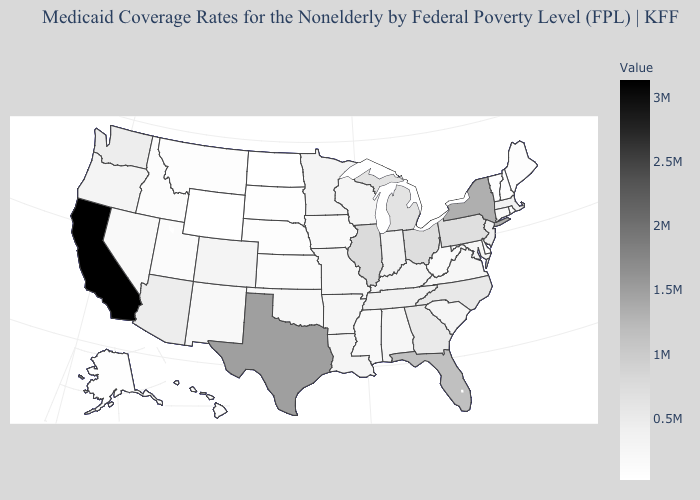Is the legend a continuous bar?
Short answer required. Yes. Which states have the lowest value in the Northeast?
Keep it brief. Vermont. Is the legend a continuous bar?
Be succinct. Yes. Among the states that border Rhode Island , which have the highest value?
Give a very brief answer. Massachusetts. Among the states that border Louisiana , which have the lowest value?
Concise answer only. Mississippi. Does California have the highest value in the USA?
Be succinct. Yes. Does Oregon have the lowest value in the West?
Be succinct. No. Which states hav the highest value in the South?
Quick response, please. Texas. 